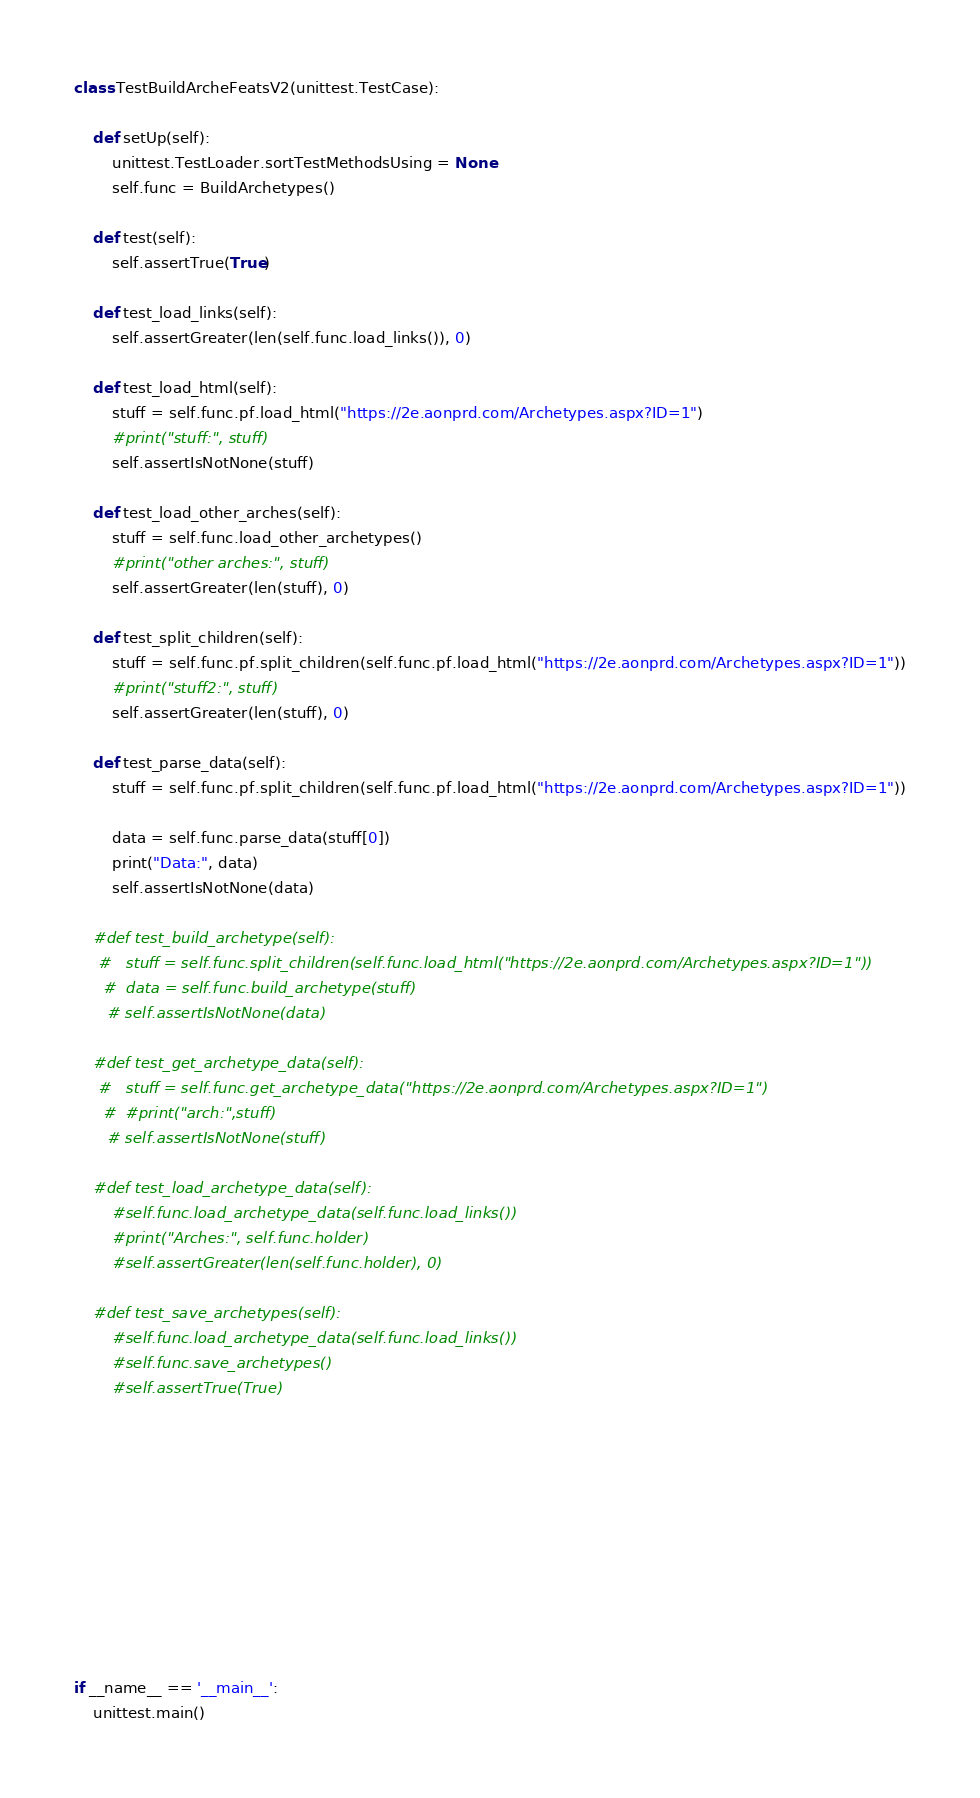Convert code to text. <code><loc_0><loc_0><loc_500><loc_500><_Python_>
class TestBuildArcheFeatsV2(unittest.TestCase):

    def setUp(self):
        unittest.TestLoader.sortTestMethodsUsing = None
        self.func = BuildArchetypes()

    def test(self):
        self.assertTrue(True)

    def test_load_links(self):
        self.assertGreater(len(self.func.load_links()), 0)
    
    def test_load_html(self):
        stuff = self.func.pf.load_html("https://2e.aonprd.com/Archetypes.aspx?ID=1")
        #print("stuff:", stuff)
        self.assertIsNotNone(stuff)
    
    def test_load_other_arches(self):
        stuff = self.func.load_other_archetypes()
        #print("other arches:", stuff)
        self.assertGreater(len(stuff), 0)

    def test_split_children(self):
        stuff = self.func.pf.split_children(self.func.pf.load_html("https://2e.aonprd.com/Archetypes.aspx?ID=1"))
        #print("stuff2:", stuff)
        self.assertGreater(len(stuff), 0)

    def test_parse_data(self):
        stuff = self.func.pf.split_children(self.func.pf.load_html("https://2e.aonprd.com/Archetypes.aspx?ID=1"))
        
        data = self.func.parse_data(stuff[0])
        print("Data:", data)
        self.assertIsNotNone(data)

    #def test_build_archetype(self):
     #   stuff = self.func.split_children(self.func.load_html("https://2e.aonprd.com/Archetypes.aspx?ID=1"))
      #  data = self.func.build_archetype(stuff)
       # self.assertIsNotNone(data)

    #def test_get_archetype_data(self):
     #   stuff = self.func.get_archetype_data("https://2e.aonprd.com/Archetypes.aspx?ID=1")
      #  #print("arch:",stuff)
       # self.assertIsNotNone(stuff)
    
    #def test_load_archetype_data(self):
        #self.func.load_archetype_data(self.func.load_links())
        #print("Arches:", self.func.holder)
        #self.assertGreater(len(self.func.holder), 0)

    #def test_save_archetypes(self):
        #self.func.load_archetype_data(self.func.load_links())
        #self.func.save_archetypes()
        #self.assertTrue(True)





    

    



if __name__ == '__main__':
    unittest.main()</code> 